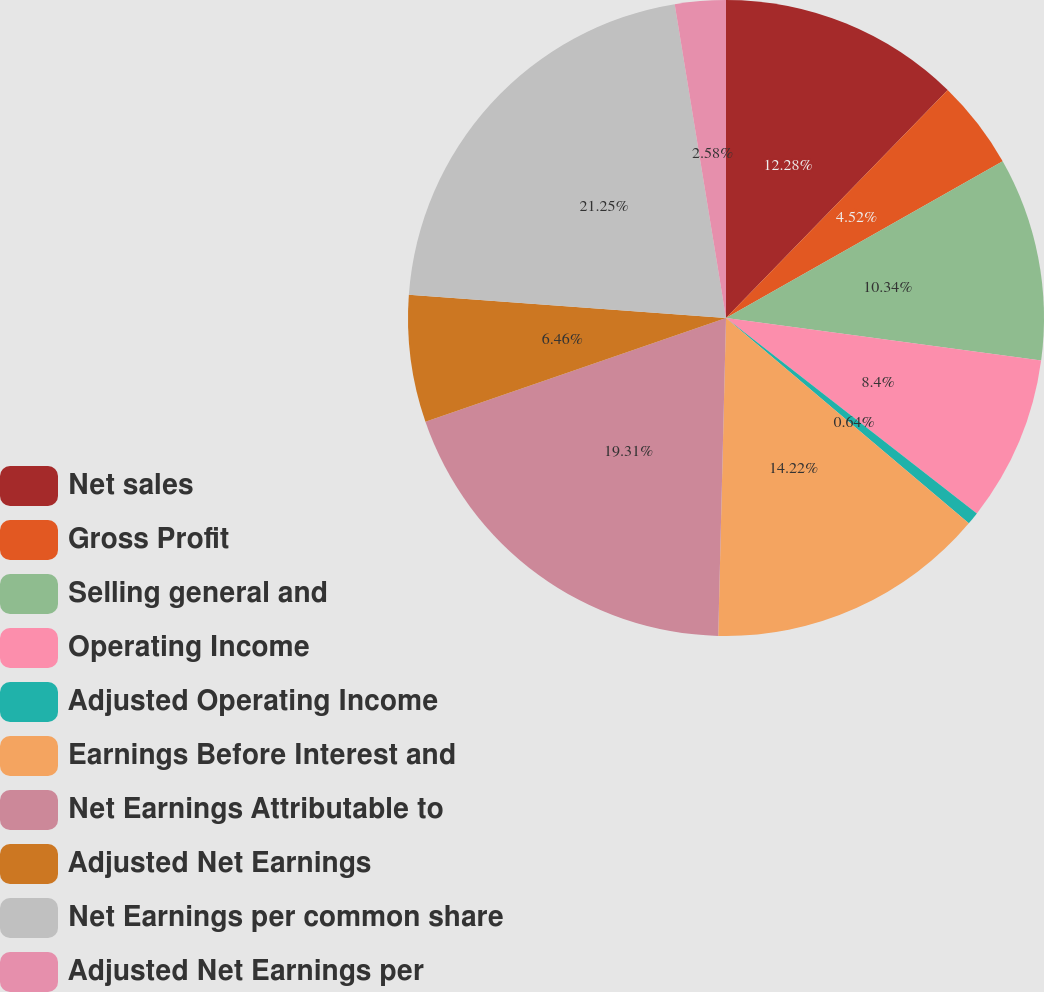Convert chart. <chart><loc_0><loc_0><loc_500><loc_500><pie_chart><fcel>Net sales<fcel>Gross Profit<fcel>Selling general and<fcel>Operating Income<fcel>Adjusted Operating Income<fcel>Earnings Before Interest and<fcel>Net Earnings Attributable to<fcel>Adjusted Net Earnings<fcel>Net Earnings per common share<fcel>Adjusted Net Earnings per<nl><fcel>12.28%<fcel>4.52%<fcel>10.34%<fcel>8.4%<fcel>0.64%<fcel>14.22%<fcel>19.32%<fcel>6.46%<fcel>21.26%<fcel>2.58%<nl></chart> 